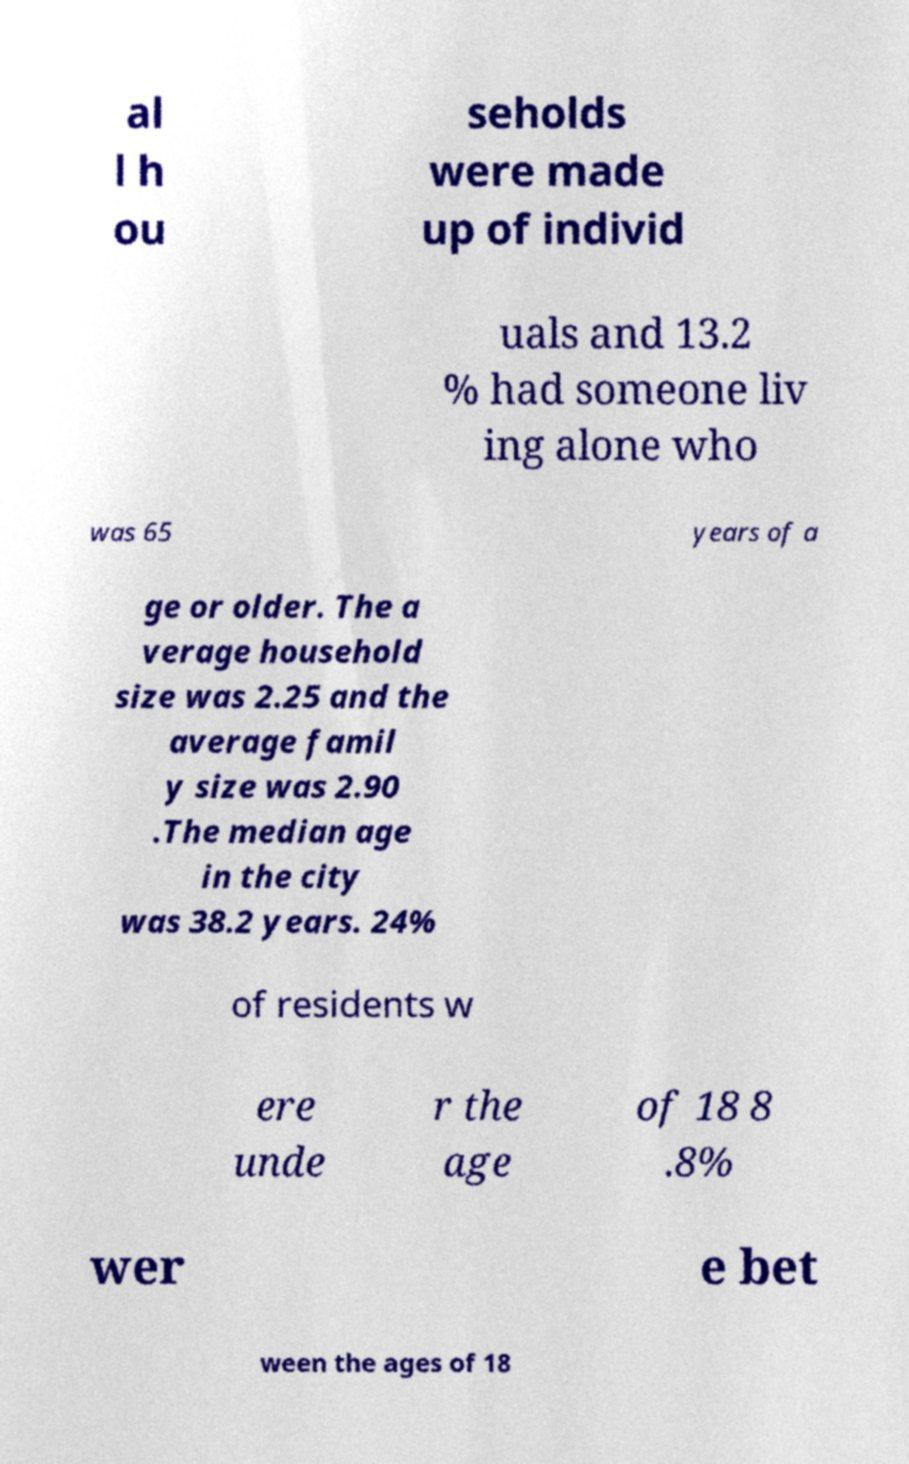Please identify and transcribe the text found in this image. al l h ou seholds were made up of individ uals and 13.2 % had someone liv ing alone who was 65 years of a ge or older. The a verage household size was 2.25 and the average famil y size was 2.90 .The median age in the city was 38.2 years. 24% of residents w ere unde r the age of 18 8 .8% wer e bet ween the ages of 18 